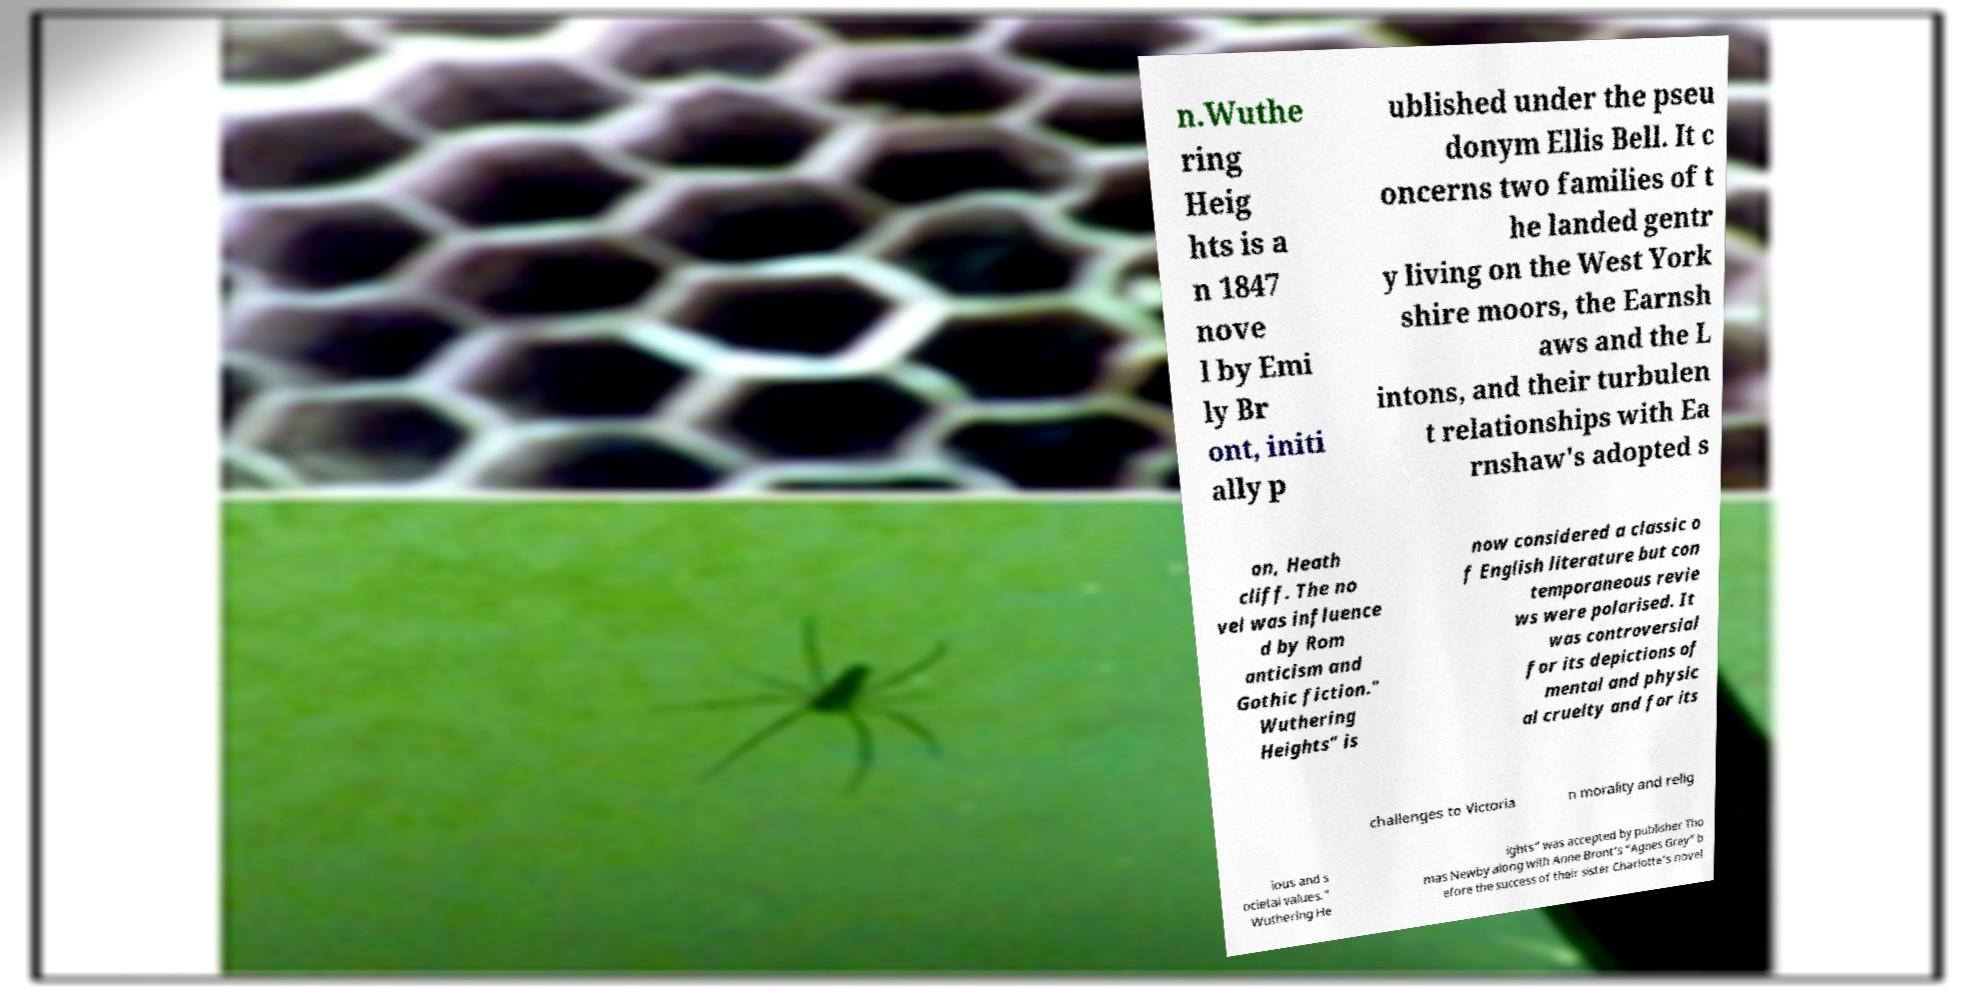Can you read and provide the text displayed in the image?This photo seems to have some interesting text. Can you extract and type it out for me? n.Wuthe ring Heig hts is a n 1847 nove l by Emi ly Br ont, initi ally p ublished under the pseu donym Ellis Bell. It c oncerns two families of t he landed gentr y living on the West York shire moors, the Earnsh aws and the L intons, and their turbulen t relationships with Ea rnshaw's adopted s on, Heath cliff. The no vel was influence d by Rom anticism and Gothic fiction." Wuthering Heights" is now considered a classic o f English literature but con temporaneous revie ws were polarised. It was controversial for its depictions of mental and physic al cruelty and for its challenges to Victoria n morality and relig ious and s ocietal values." Wuthering He ights" was accepted by publisher Tho mas Newby along with Anne Bront's "Agnes Grey" b efore the success of their sister Charlotte's novel 